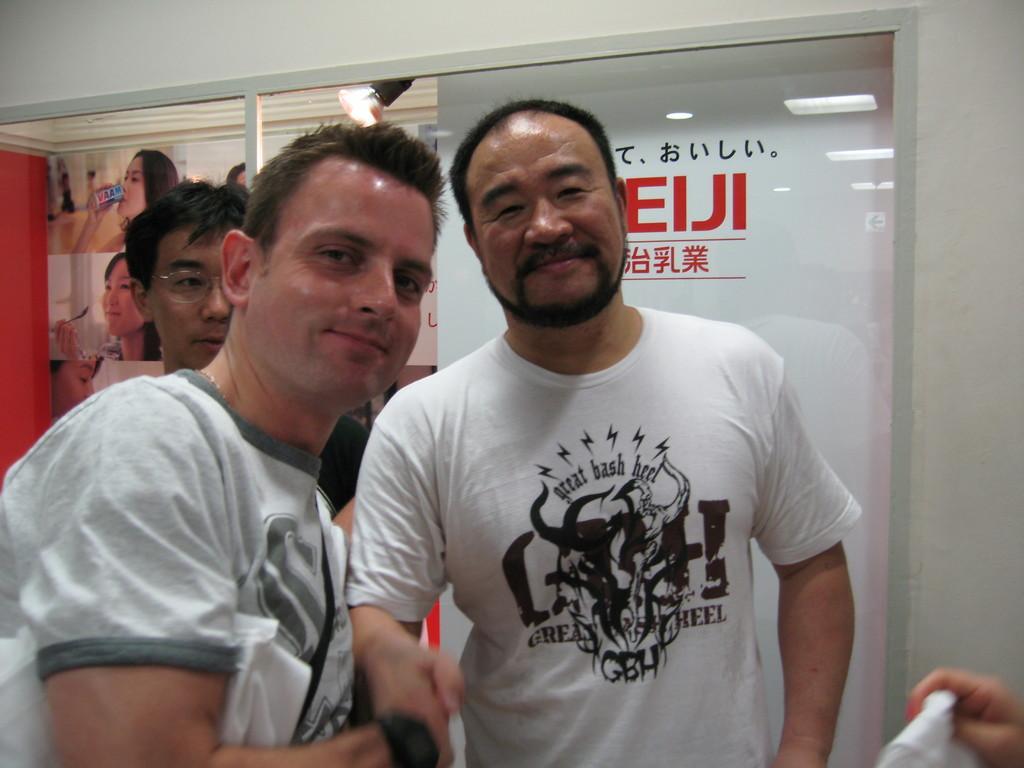In one or two sentences, can you explain what this image depicts? In this picture, the two men in white T-shirts are shaking their hands. Both of them are smiling. Behind them, the man who is wearing spectacles is standing. Behind them, we see a banner with some text written on it. Beside that, we see a red wall on which posters are pasted. 